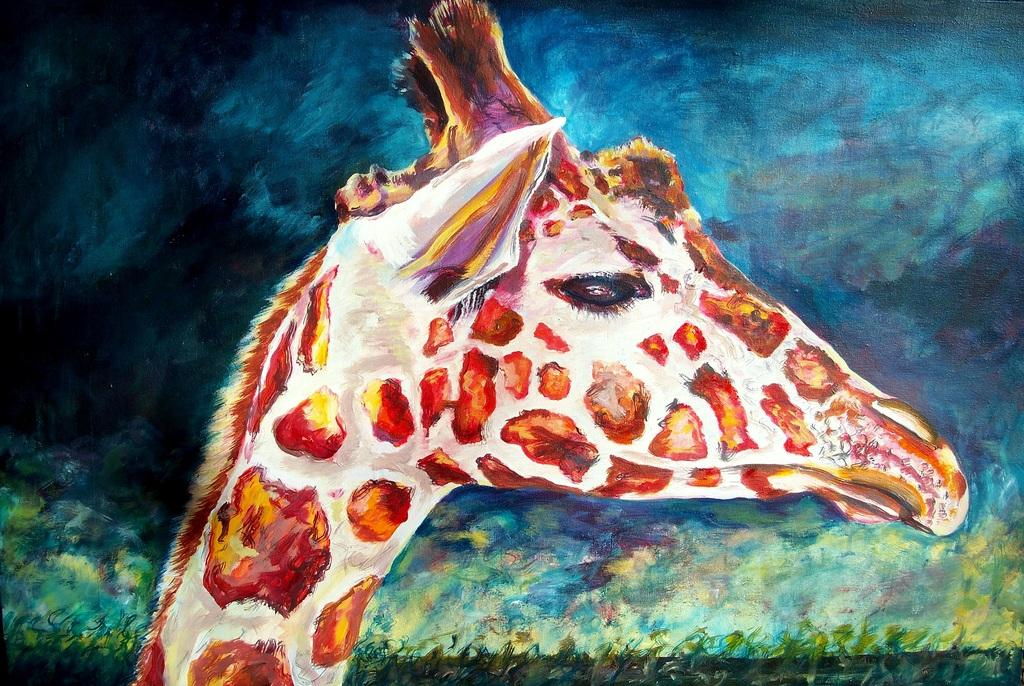What is the main subject of the image? There is a picture of a giraffe in the image. What color is the background of the image? The background of the image is blue in color. Can you tell me which actor is standing next to the giraffe in the image? There are no actors present in the image; it features a picture of a giraffe with a blue background. Is there a garden visible in the image? There is no garden present in the image; it features a picture of a giraffe with a blue background. 